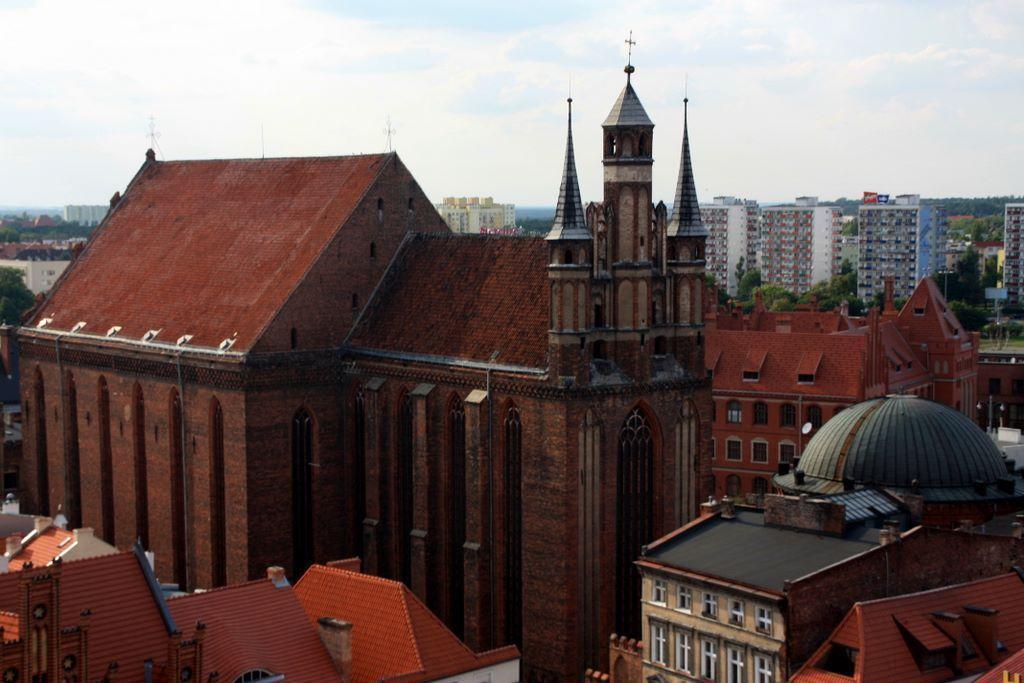Could you give a brief overview of what you see in this image? These are the buildings in red, on the right side there are big buildings. At the top it's a sky. 